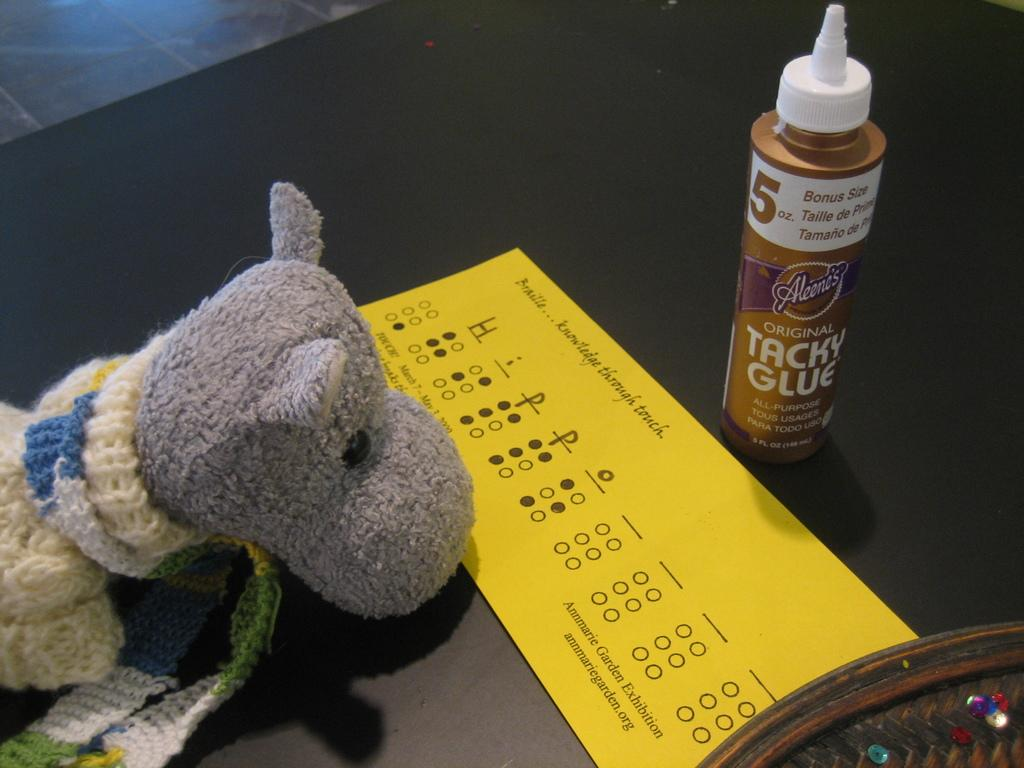<image>
Relay a brief, clear account of the picture shown. Tacky glue is needed for this craft project shown. 